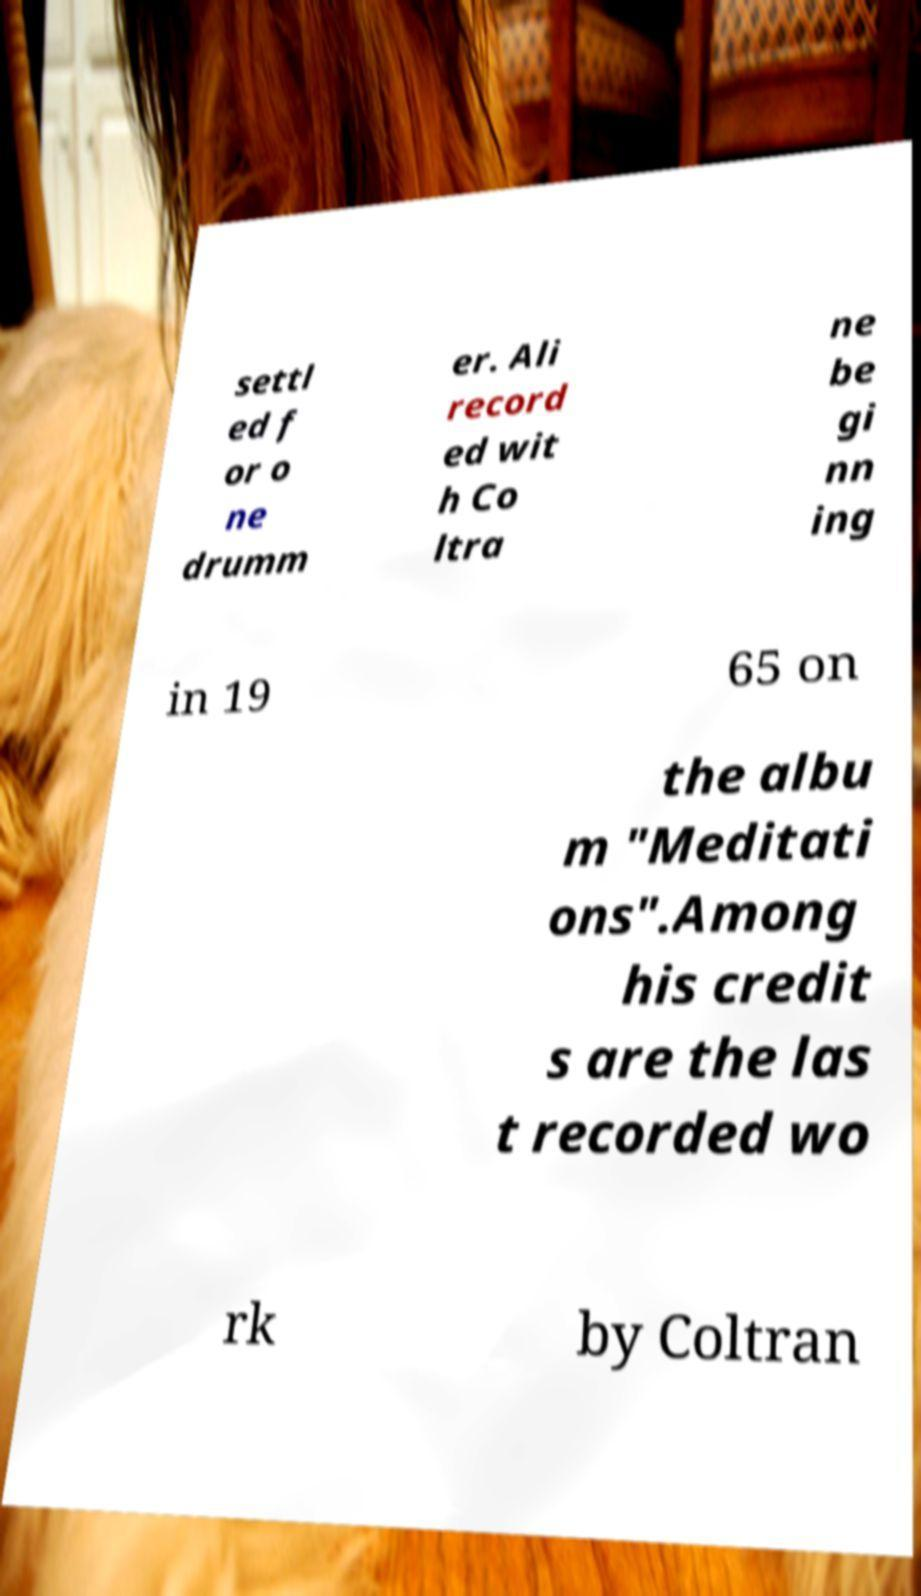Can you accurately transcribe the text from the provided image for me? settl ed f or o ne drumm er. Ali record ed wit h Co ltra ne be gi nn ing in 19 65 on the albu m "Meditati ons".Among his credit s are the las t recorded wo rk by Coltran 